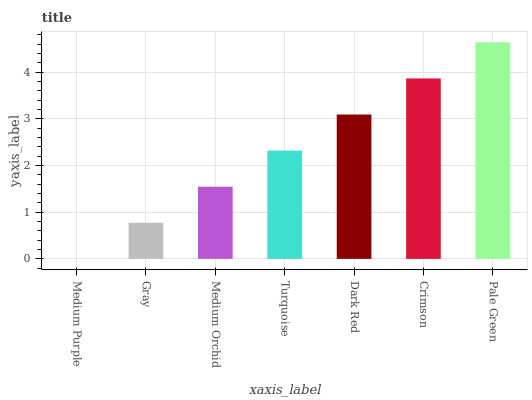Is Medium Purple the minimum?
Answer yes or no. Yes. Is Pale Green the maximum?
Answer yes or no. Yes. Is Gray the minimum?
Answer yes or no. No. Is Gray the maximum?
Answer yes or no. No. Is Gray greater than Medium Purple?
Answer yes or no. Yes. Is Medium Purple less than Gray?
Answer yes or no. Yes. Is Medium Purple greater than Gray?
Answer yes or no. No. Is Gray less than Medium Purple?
Answer yes or no. No. Is Turquoise the high median?
Answer yes or no. Yes. Is Turquoise the low median?
Answer yes or no. Yes. Is Dark Red the high median?
Answer yes or no. No. Is Gray the low median?
Answer yes or no. No. 